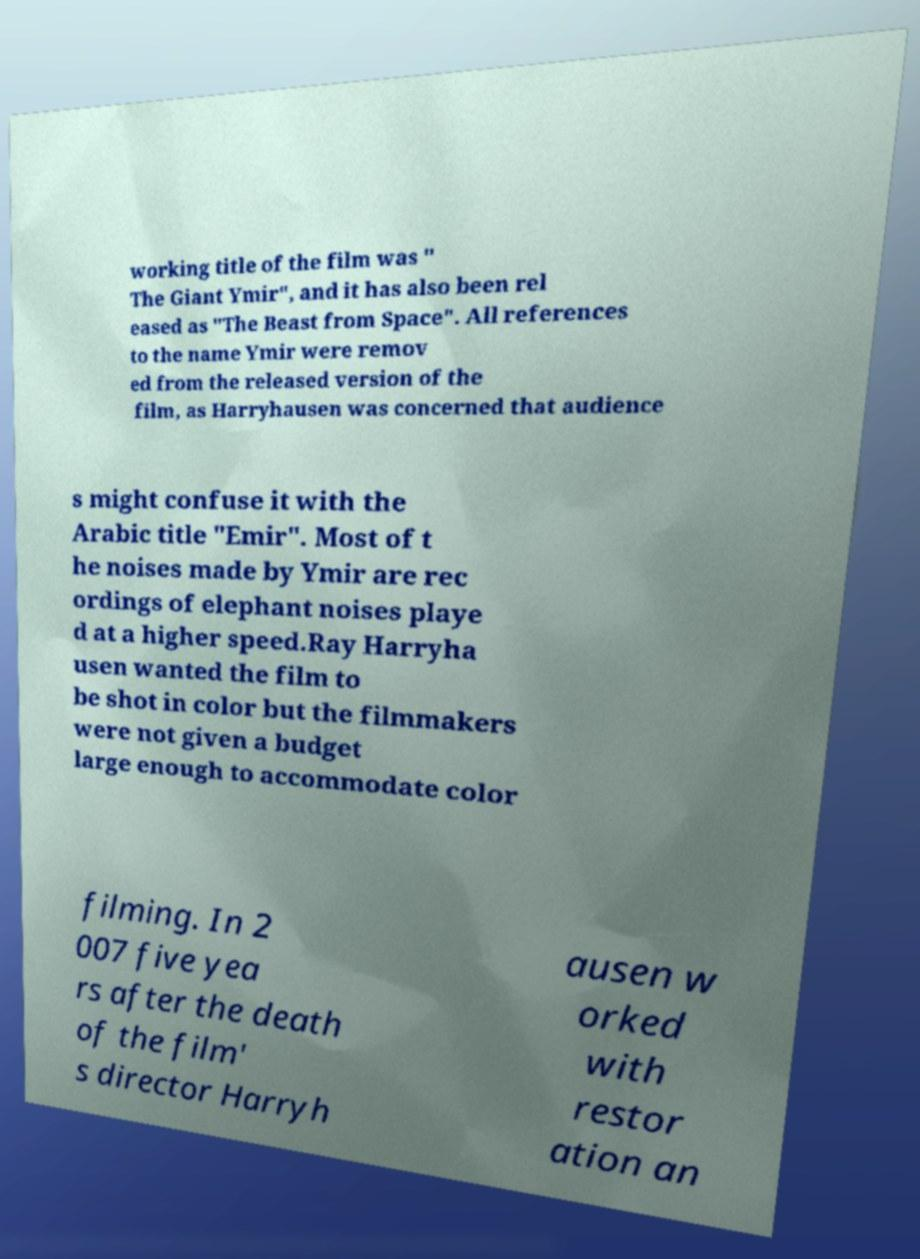There's text embedded in this image that I need extracted. Can you transcribe it verbatim? working title of the film was " The Giant Ymir", and it has also been rel eased as "The Beast from Space". All references to the name Ymir were remov ed from the released version of the film, as Harryhausen was concerned that audience s might confuse it with the Arabic title "Emir". Most of t he noises made by Ymir are rec ordings of elephant noises playe d at a higher speed.Ray Harryha usen wanted the film to be shot in color but the filmmakers were not given a budget large enough to accommodate color filming. In 2 007 five yea rs after the death of the film' s director Harryh ausen w orked with restor ation an 